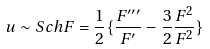<formula> <loc_0><loc_0><loc_500><loc_500>u \sim S c h F = \frac { 1 } { 2 } \{ \frac { F ^ { \prime \prime \prime } } { F ^ { \prime } } - \frac { 3 } { 2 } \frac { F ^ { 2 } } { F ^ { 2 } } \}</formula> 